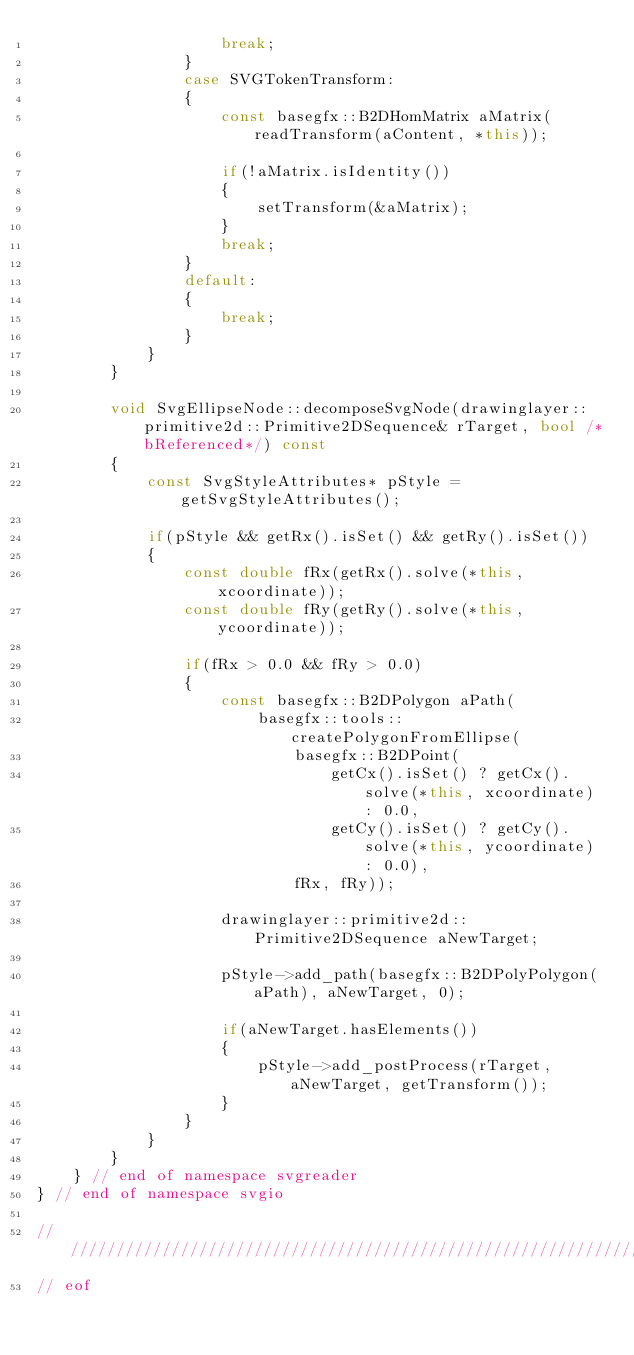<code> <loc_0><loc_0><loc_500><loc_500><_C++_>                    break;
                }
                case SVGTokenTransform:
                {
                    const basegfx::B2DHomMatrix aMatrix(readTransform(aContent, *this));

                    if(!aMatrix.isIdentity())
                    {
                        setTransform(&aMatrix);
                    }
                    break;
                }
                default:
                {
                    break;
                }
            }
        }

        void SvgEllipseNode::decomposeSvgNode(drawinglayer::primitive2d::Primitive2DSequence& rTarget, bool /*bReferenced*/) const
        {
            const SvgStyleAttributes* pStyle = getSvgStyleAttributes();

            if(pStyle && getRx().isSet() && getRy().isSet())
            {
                const double fRx(getRx().solve(*this, xcoordinate));
                const double fRy(getRy().solve(*this, ycoordinate));

                if(fRx > 0.0 && fRy > 0.0)
                {
                    const basegfx::B2DPolygon aPath(
                        basegfx::tools::createPolygonFromEllipse(
                            basegfx::B2DPoint(
                                getCx().isSet() ? getCx().solve(*this, xcoordinate) : 0.0,
                                getCy().isSet() ? getCy().solve(*this, ycoordinate) : 0.0),
                            fRx, fRy));

                    drawinglayer::primitive2d::Primitive2DSequence aNewTarget;

                    pStyle->add_path(basegfx::B2DPolyPolygon(aPath), aNewTarget, 0);
                    
                    if(aNewTarget.hasElements())
                    {
                        pStyle->add_postProcess(rTarget, aNewTarget, getTransform());
                    }
                }
            }
        }
    } // end of namespace svgreader
} // end of namespace svgio

//////////////////////////////////////////////////////////////////////////////
// eof
</code> 